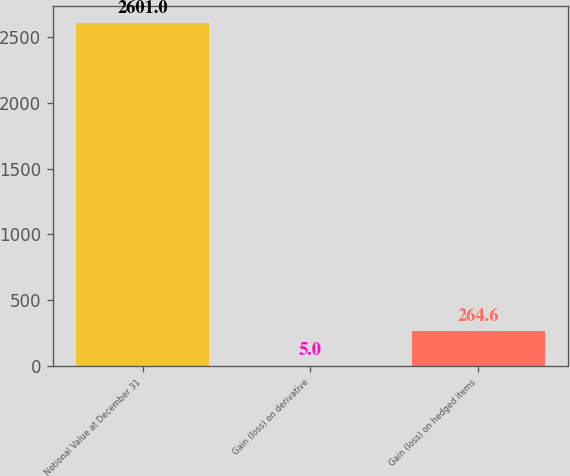Convert chart. <chart><loc_0><loc_0><loc_500><loc_500><bar_chart><fcel>Notional Value at December 31<fcel>Gain (loss) on derivative<fcel>Gain (loss) on hedged items<nl><fcel>2601<fcel>5<fcel>264.6<nl></chart> 